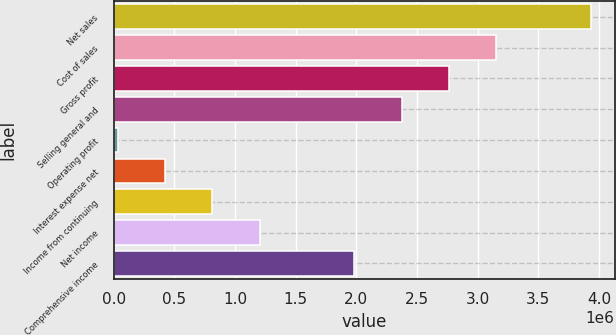Convert chart to OTSL. <chart><loc_0><loc_0><loc_500><loc_500><bar_chart><fcel>Net sales<fcel>Cost of sales<fcel>Gross profit<fcel>Selling general and<fcel>Operating profit<fcel>Interest expense net<fcel>Income from continuing<fcel>Net income<fcel>Comprehensive income<nl><fcel>3.93359e+06<fcel>3.15356e+06<fcel>2.76355e+06<fcel>2.37353e+06<fcel>33440<fcel>423455<fcel>813470<fcel>1.20349e+06<fcel>1.98352e+06<nl></chart> 